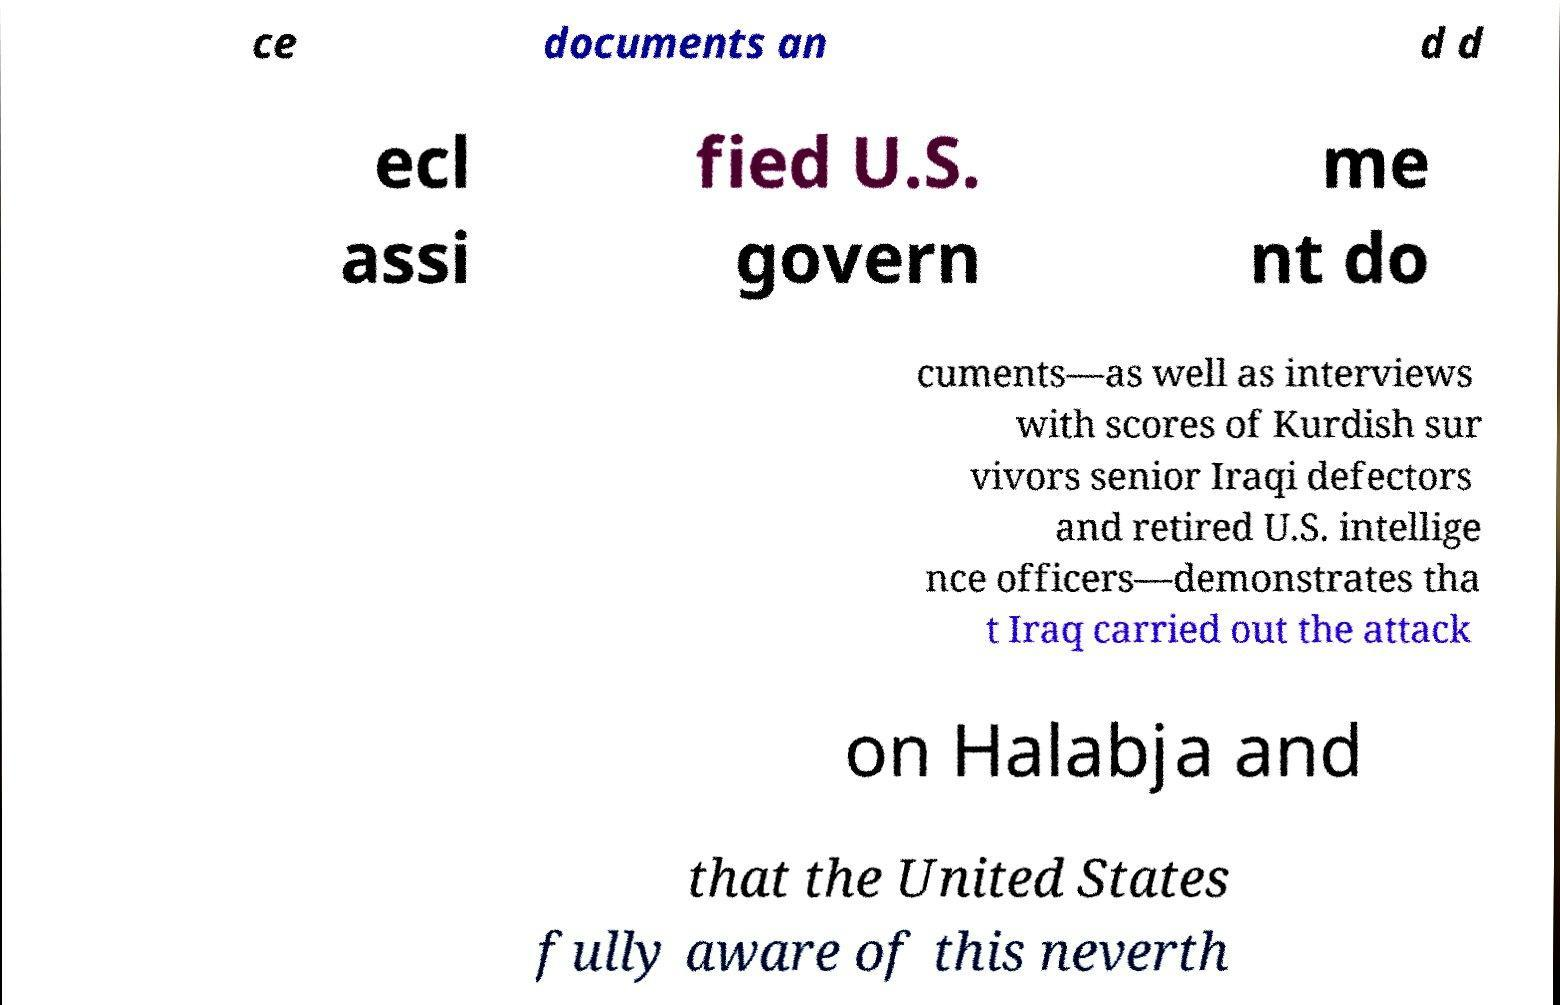There's text embedded in this image that I need extracted. Can you transcribe it verbatim? ce documents an d d ecl assi fied U.S. govern me nt do cuments—as well as interviews with scores of Kurdish sur vivors senior Iraqi defectors and retired U.S. intellige nce officers—demonstrates tha t Iraq carried out the attack on Halabja and that the United States fully aware of this neverth 